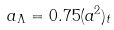<formula> <loc_0><loc_0><loc_500><loc_500>a _ { \Lambda } = 0 . 7 5 ( a ^ { 2 } ) _ { t }</formula> 